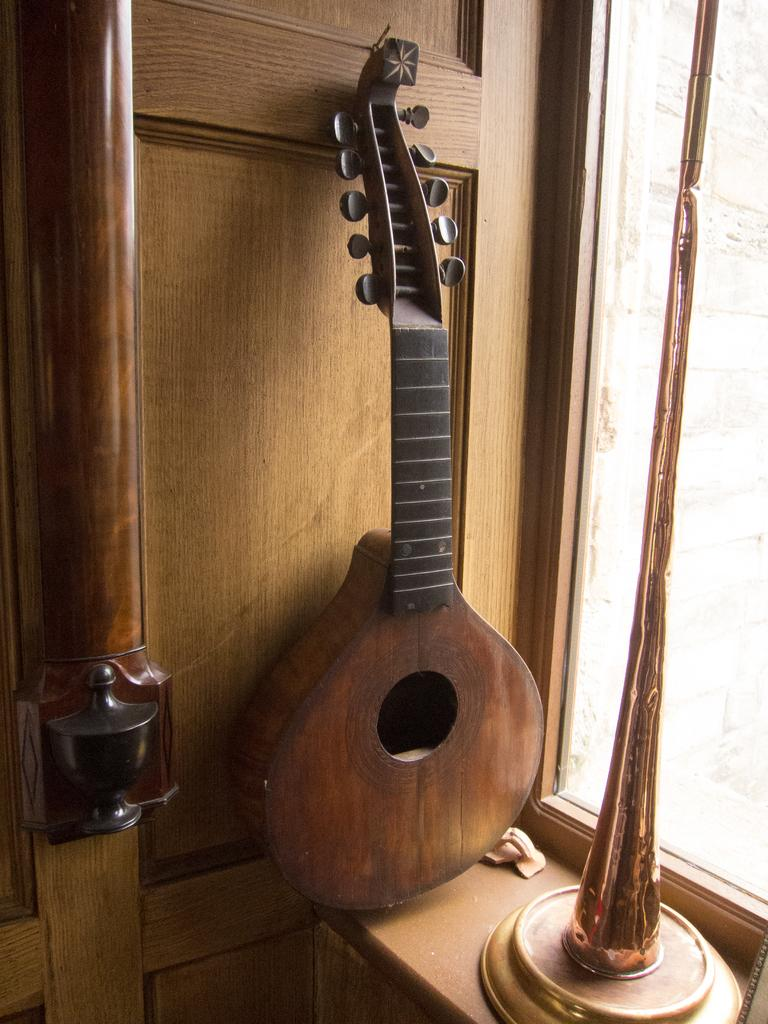What musical instrument is present in the image? There is a guitar in the image. Where is the guitar placed? The guitar is placed on a table. Can you describe the location of the table in relation to other elements in the image? The table is located near a window. What type of soup is being prepared on the guitar in the image? There is no soup or cooking activity present in the image; it features a guitar placed on a table. What type of polish is being applied to the guitar in the image? There is no polish or polishing activity present in the image; it features a guitar placed on a table. 